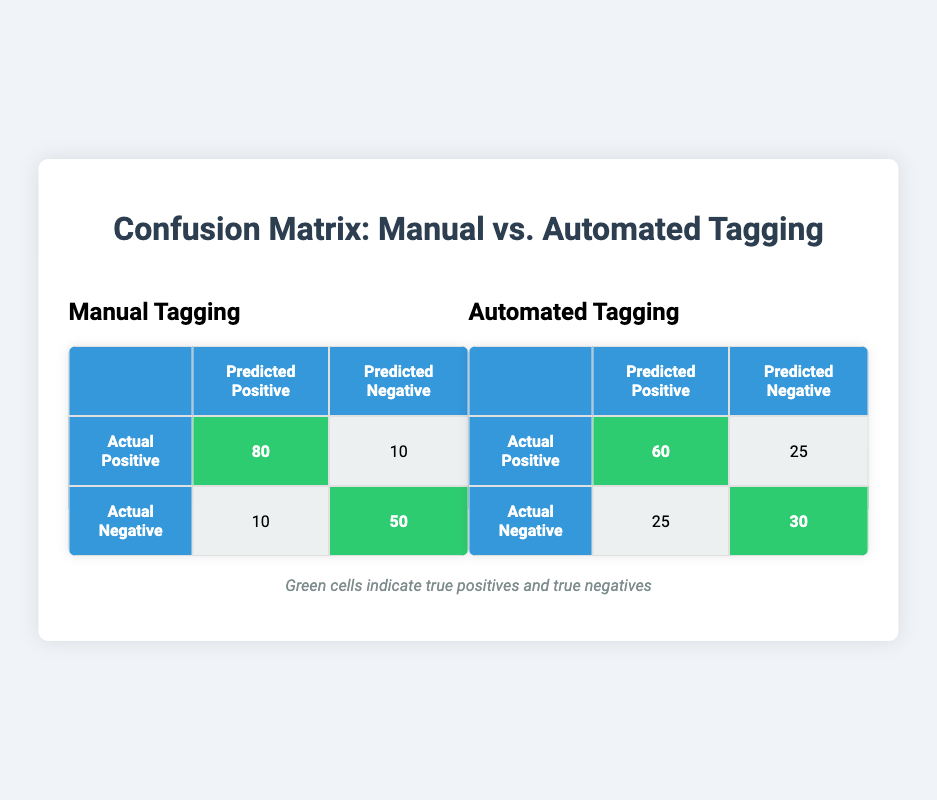What is the true positive rate for manual tagging? The true positive rate (TPR) is calculated as the number of true positives divided by the sum of true positives and false negatives. For manual tagging, TPR = 80 / (80 + 10) = 80 / 90 = 0.888... or approximately 88.89%.
Answer: 88.89% How many true positives are there in automated tagging? The table shows that there are 60 true positives in automated tagging as indicated in the corresponding cell.
Answer: 60 What is the total number of false positives for both manual and automated tagging combined? We add the false positives for both methods: Manual false positives = 10 and Automated false positives = 25, so the total = 10 + 25 = 35.
Answer: 35 Which tagging method has a higher true negative count? The true negatives for manual tagging are 50, while for automated tagging, they are 30. Since 50 is greater than 30, manual tagging has a higher true negative count.
Answer: Manual tagging Is the true positive count for automated tagging greater than that of manual tagging? The true positive count for automated tagging is 60, while for manual tagging, it is 80. Since 60 is less than 80, this statement is false.
Answer: No What is the false negative rate for automated tagging? The false negative rate (FNR) is calculated by dividing the number of false negatives by the sum of true positives and false negatives. For automated tagging, FNR = 25 / (60 + 25) = 25 / 85 = 0.294... or approximately 29.41%.
Answer: 29.41% What is the difference in true positive count between manual and automated tagging? The difference is found by subtracting the true positive count of automated tagging from that of manual tagging: 80 (manual) - 60 (automated) = 20.
Answer: 20 How many instances were incorrectly predicted as negative in manual tagging? In manual tagging, the count of instances incorrectly predicted as negative is given directly by the false negative value, which is 10.
Answer: 10 What is the total number of positives predicted in manual tagging? The total number of predicted positives in manual tagging is the sum of true positives and false positives: 80 (true positives) + 10 (false positives) = 90.
Answer: 90 